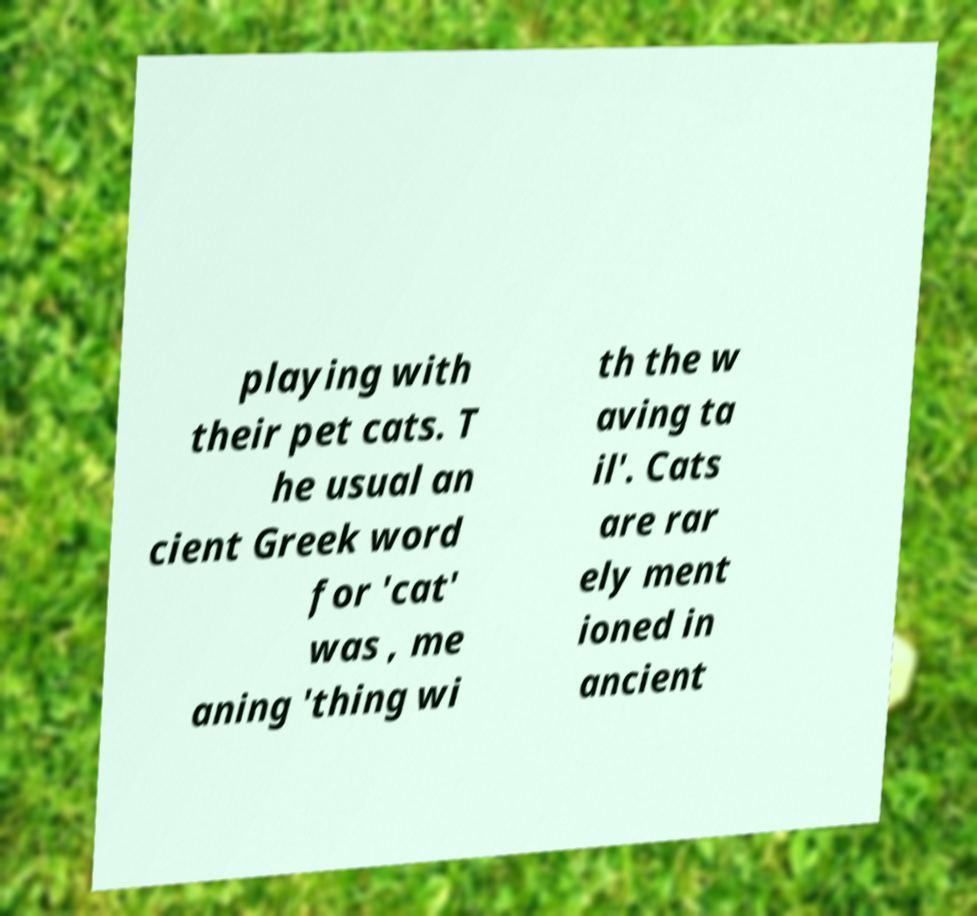There's text embedded in this image that I need extracted. Can you transcribe it verbatim? playing with their pet cats. T he usual an cient Greek word for 'cat' was , me aning 'thing wi th the w aving ta il'. Cats are rar ely ment ioned in ancient 